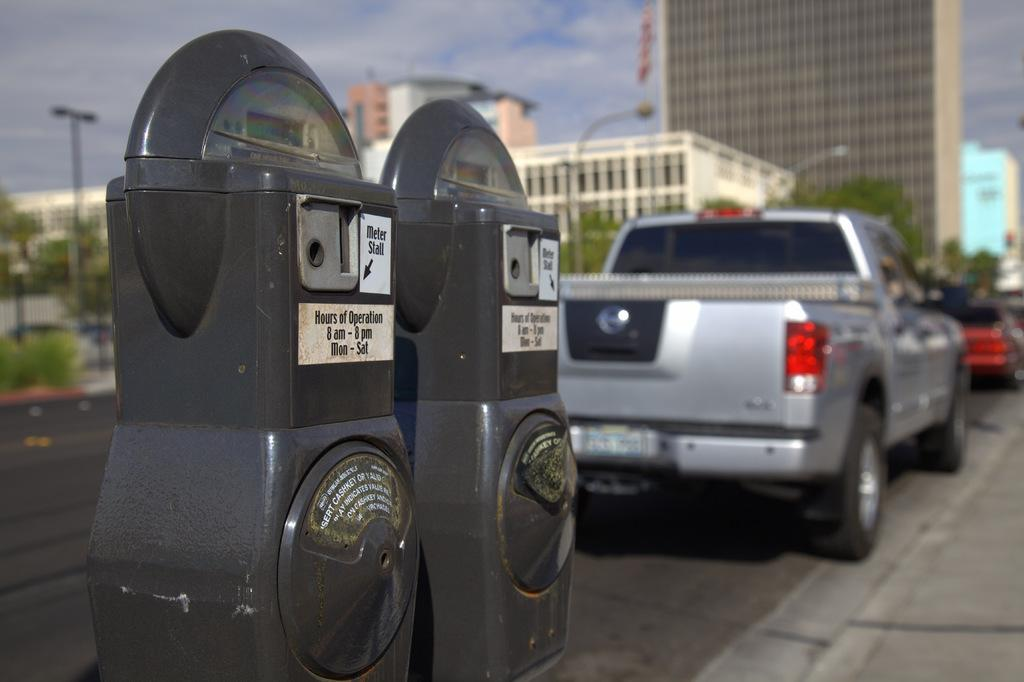<image>
Summarize the visual content of the image. a parking meter that has the hours of operation on the front 